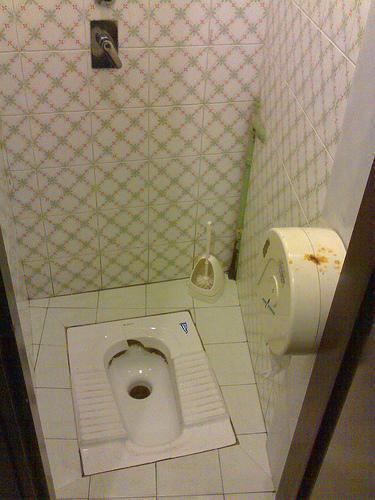How many people are in this picture?
Give a very brief answer. 0. 